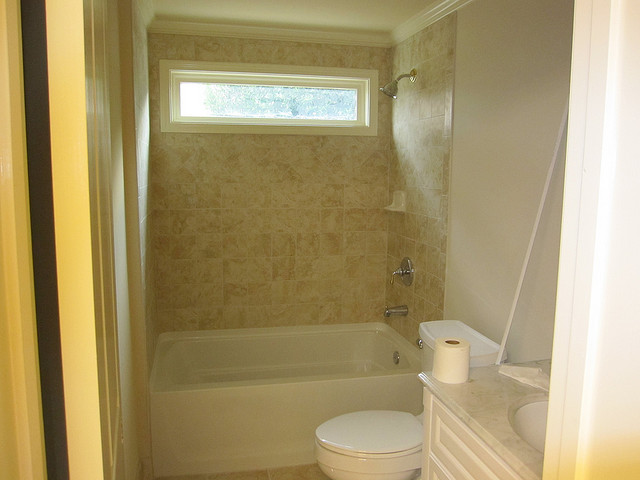Considering the layout, what improvements could be made to this bathroom for better functionality? Improvements could include adding storage shelves or a medicine cabinet above the toilet for additional space, installing a shower caddy or corner shelves in the bathing area for toiletries, and potentially updating the lighting fixtures to brighten up the space and enhance the ambiance. 